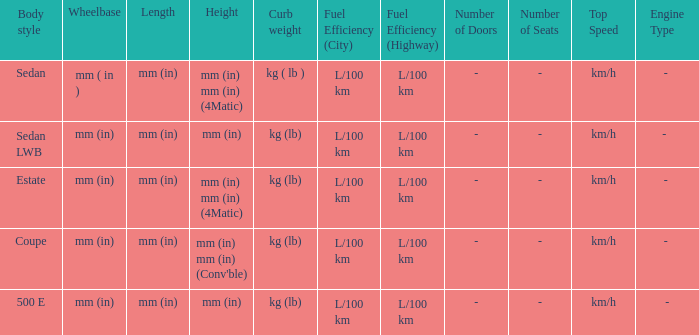What's the curb weight of the model with a wheelbase of mm (in) and height of mm (in) mm (in) (4Matic)? Kg ( lb ), kg (lb). 